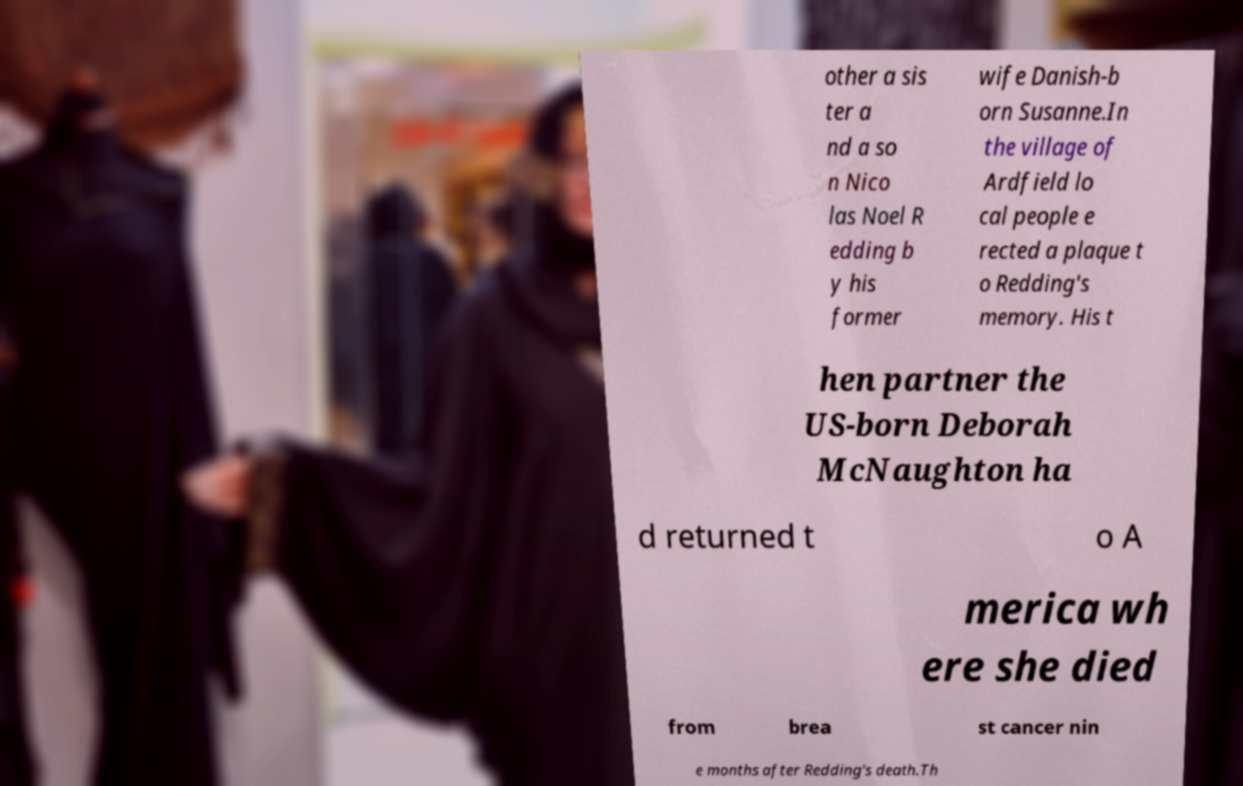For documentation purposes, I need the text within this image transcribed. Could you provide that? other a sis ter a nd a so n Nico las Noel R edding b y his former wife Danish-b orn Susanne.In the village of Ardfield lo cal people e rected a plaque t o Redding's memory. His t hen partner the US-born Deborah McNaughton ha d returned t o A merica wh ere she died from brea st cancer nin e months after Redding's death.Th 